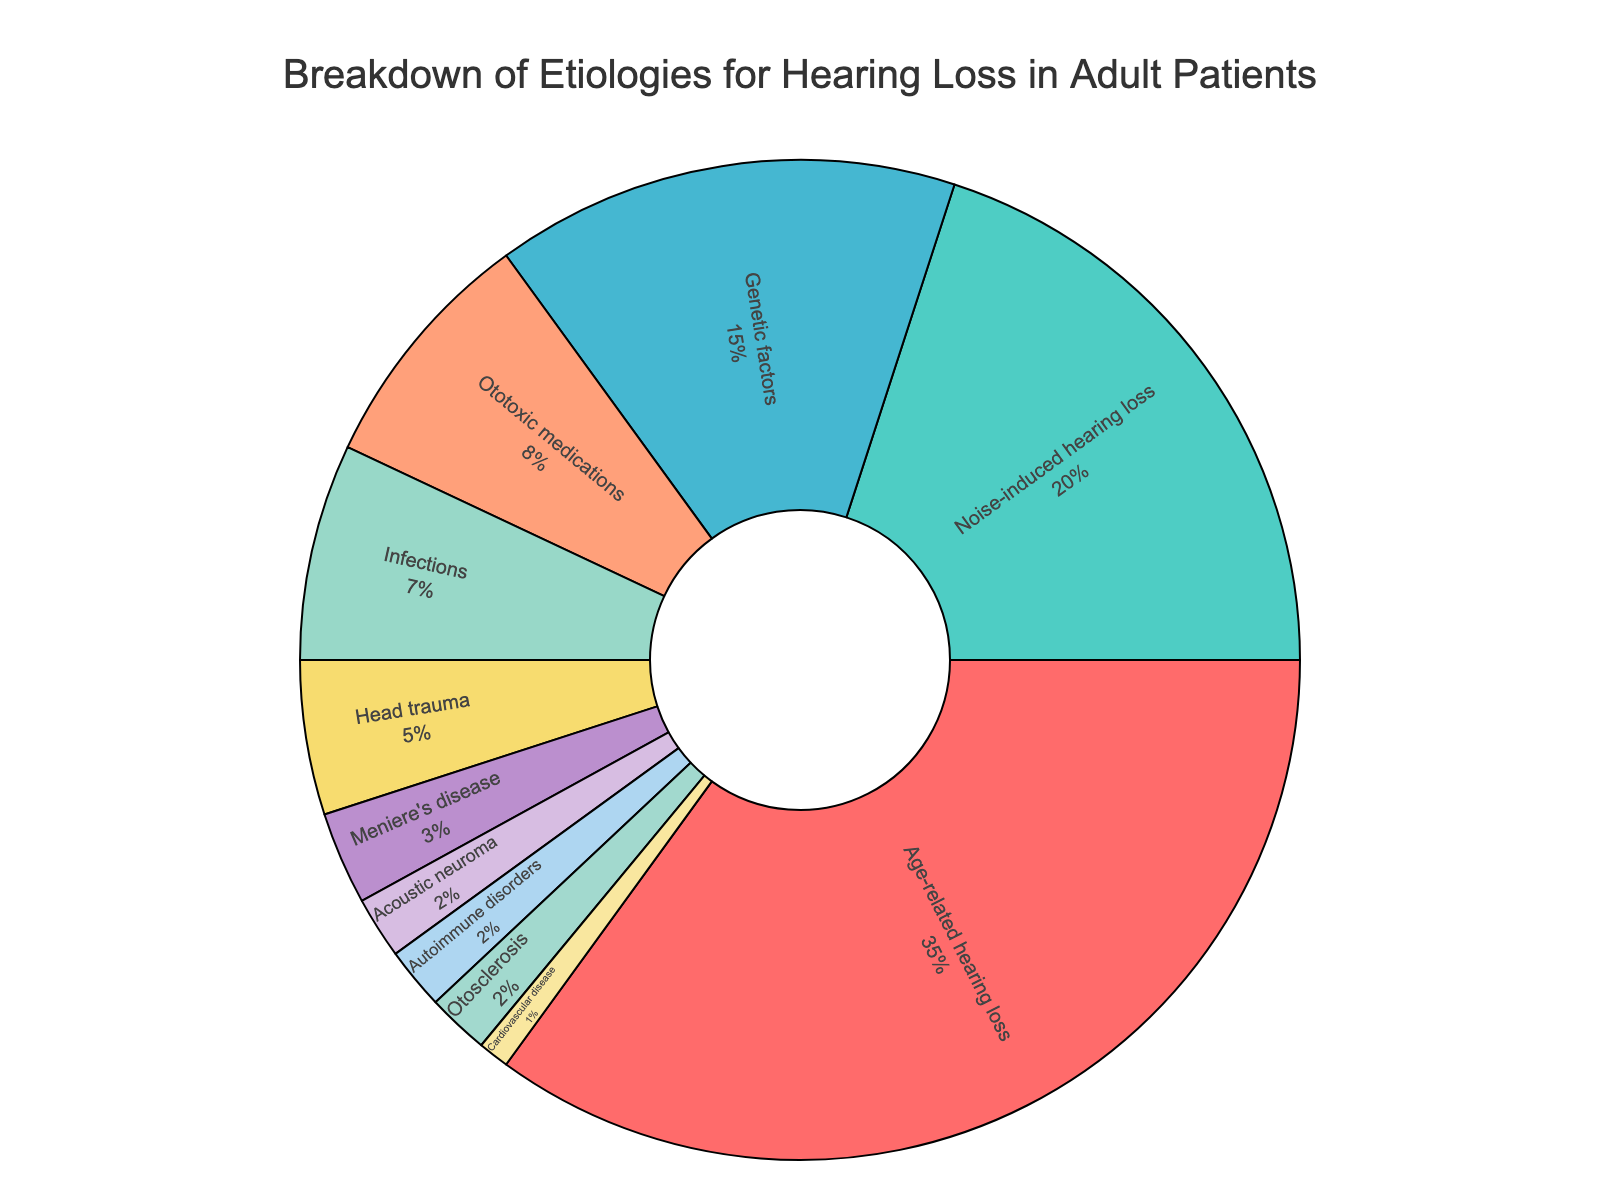How many etiologies are listed in the chart? The pie chart lists different etiologies for hearing loss, each represented by a distinct segment. Counting the segments gives the total number of etiologies.
Answer: 11 Which etiology has the highest percentage? Identify the largest segment in the pie chart, which corresponds to the etiology with the highest percentage.
Answer: Age-related hearing loss What is the combined percentage of noise-induced hearing loss and genetic factors? Locate the segments for noise-induced hearing loss and genetic factors, noting their percentages (20% and 15% respectively). Add these percentages together to get the combined percentage.
Answer: 35% Are infections or head trauma more common, and by how much? Compare the percentages for infections and head trauma. Infections have 7%, and head trauma has 5%. Subtract the smaller percentage from the larger one.
Answer: Infections, by 2% What percentage of etiologies are less than 5% each? Identify segments with percentages less than 5%: Head trauma (5%), Meniere's disease (3%), Acoustic neuroma (2%), Autoimmune disorders (2%), Otosclerosis (2%), and Cardiovascular disease (1%). Add these percentages.
Answer: 15% What color represents genetic factors, and where is it located on the chart? In the pie chart, identify the segment labeled 'Genetic factors'. Note its color and approximate position in the clockwise rotation starting from the top (90 degrees).
Answer: Light blue, located towards the upper right Does age-related hearing loss have a larger percentage than the combined percentage of ototoxic medications, infections, and head trauma? Calculate the combined percentage of ototoxic medications (8%), infections (7%), and head trauma (5%): 8% + 7% + 5% = 20%. Compare it with the percentage for age-related hearing loss (35%).
Answer: Yes What is the smallest etiology listed, and what percentage does it represent? Find the smallest segment in the pie chart. Note the etiology and its corresponding percentage.
Answer: Cardiovascular disease, 1% Does the combined percentage of etiology for Meniere's disease, acoustic neuroma, autoimmune disorders, and otosclerosis equal the percentage for noise-induced hearing loss? Add the percentages for Meniere's disease (3%), acoustic neuroma (2%), autoimmune disorders (2%), and otosclerosis (2%): 3% + 2% + 2% + 2% = 9%. Compare with noise-induced hearing loss (20%).
Answer: No What's the percentage difference between the highest and lowest etiologies listed? Identify the highest percentage (age-related hearing loss: 35%) and the lowest percentage (cardiovascular disease: 1%). Subtract the lowest from the highest.
Answer: 34% 